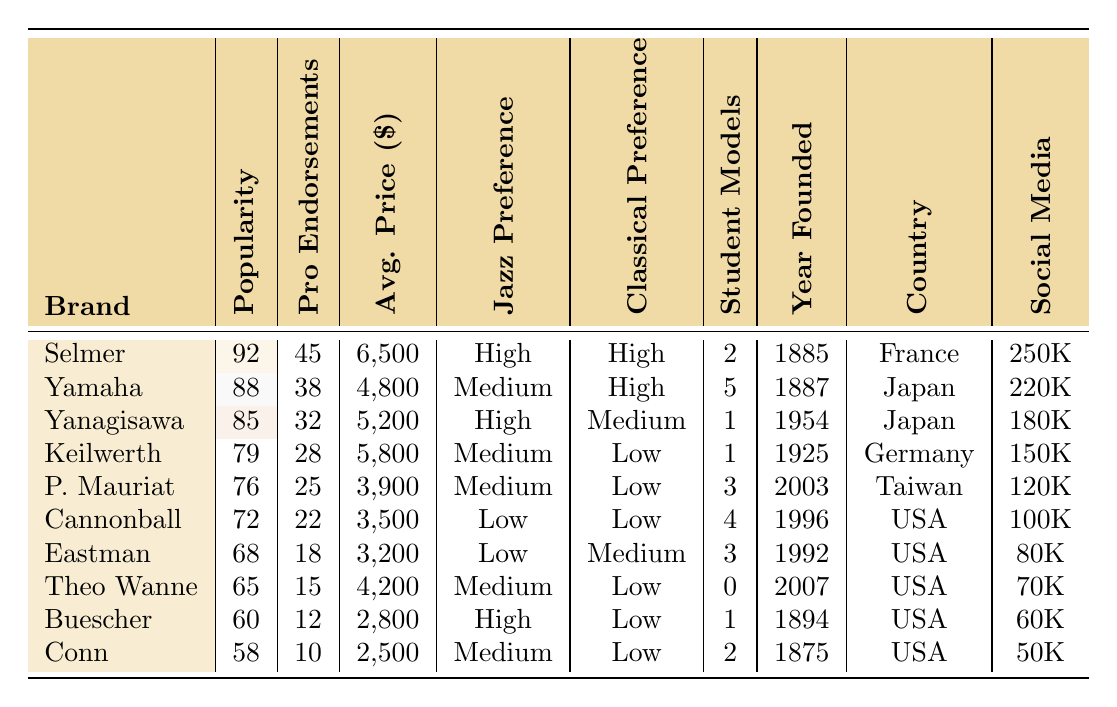What is the average price of Selmer saxophones? The average price of Selmer saxophones is given as $6,500, directly referenced in the table.
Answer: $6,500 Which saxophone brand has the highest popularity score? The table shows that Selmer has the highest popularity score of 92.
Answer: Selmer How many professional endorsements does Yanagisawa have? According to the table, Yanagisawa is endorsed by 32 professionals.
Answer: 32 Which brand originated from Germany? The table indicates that Keilwerth is the only brand listed from Germany.
Answer: Keilwerth How many total professional endorsements do the top three brands (Selmer, Yamaha, Yanagisawa) have combined? The endorsements for the top three brands are 45 (Selmer) + 38 (Yamaha) + 32 (Yanagisawa) = 115 endorsements in total.
Answer: 115 Is there a brand with more than 50% of social media followers than P. Mauriat? First, we check the number of social media followers for P. Mauriat, which is 120,000. The next step is to see which brands have more than 60,000 followers (50% of 120,000) and find that Selmer, Yamaha, Yanagisawa, Keilwerth, Cannonball, Eastman, and Buescher all have more. Thus, yes, there are brands exceeding this number.
Answer: Yes Which saxophone brand has the lowest average price and what is that price? From the table, Conn has the lowest average price of $2,500 among all brands mentioned.
Answer: $2,500 How many student-friendly models does Yamaha have compared to the total number of student-friendly models offered by all brands? Yamaha has 5 student-friendly models. The sum of all student-friendly models is 2 + 5 + 1 + 1 + 3 + 4 + 3 + 0 + 1 + 2 = 22. This indicates that Yamaha has approximately 22.73% of the total models.
Answer: 5 What proportion of brands have a 'High' preference among jazz players? To find the proportion, we count the brands marked as 'High' for jazz preference, which are Selmer, Yanagisawa, and Buescher (a total of 3). There are 10 brands in total, so the proportion is 3/10 = 0.3 or 30%.
Answer: 30% Which brand has the deepest historical roots, and in what year was it founded? Referring to the founded years, Selmer has the earliest foundation date listed, which is 1885.
Answer: Selmer, 1885 Are there more student-friendly models for Cannonball or Eastman? According to the table, Cannonball has 4 student-friendly models while Eastman has 3, making Cannonball the brand with more models.
Answer: Cannonball 